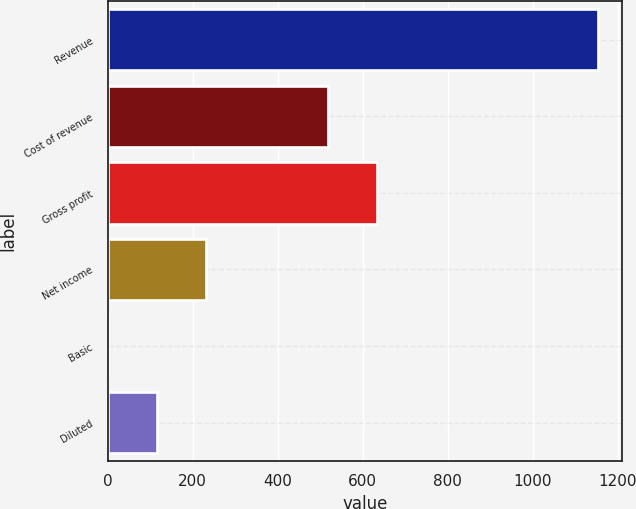Convert chart to OTSL. <chart><loc_0><loc_0><loc_500><loc_500><bar_chart><fcel>Revenue<fcel>Cost of revenue<fcel>Gross profit<fcel>Net income<fcel>Basic<fcel>Diluted<nl><fcel>1153<fcel>519<fcel>634.3<fcel>230.65<fcel>0.05<fcel>115.35<nl></chart> 